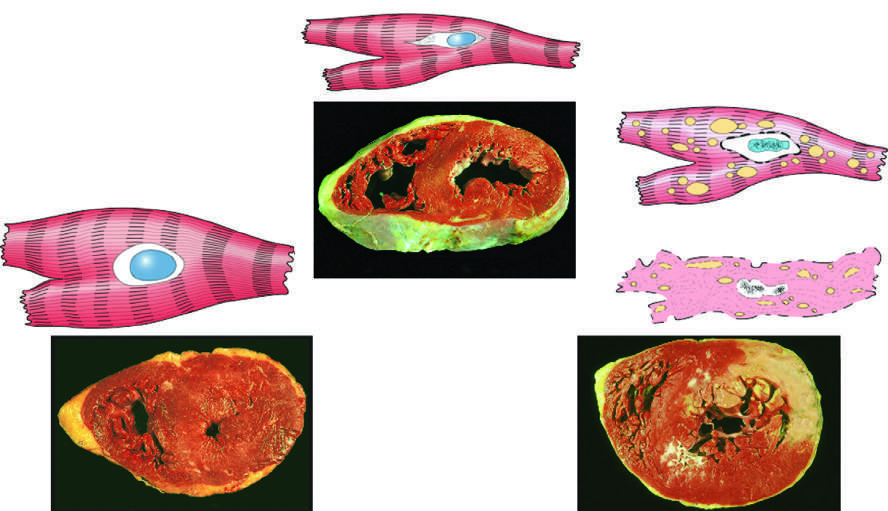s failure to stain due to enzyme loss after cell death?
Answer the question using a single word or phrase. Yes 